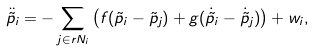<formula> <loc_0><loc_0><loc_500><loc_500>\ddot { \tilde { p } } _ { i } = - \sum _ { j \in r { N } _ { i } } \left ( f ( \tilde { p } _ { i } - \tilde { p } _ { j } ) + g ( \dot { \tilde { p } } _ { i } - \dot { \tilde { p } } _ { j } ) \right ) + w _ { i } ,</formula> 